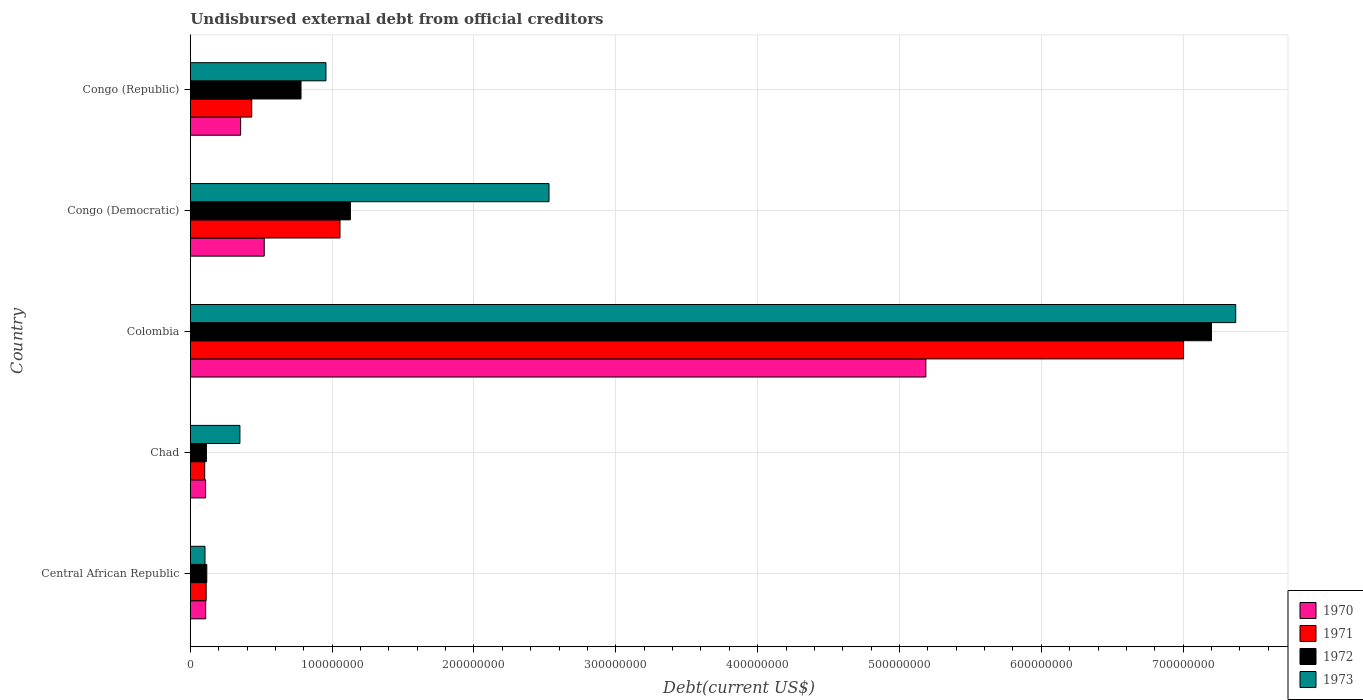How many different coloured bars are there?
Offer a terse response. 4. Are the number of bars per tick equal to the number of legend labels?
Ensure brevity in your answer.  Yes. How many bars are there on the 4th tick from the top?
Offer a very short reply. 4. How many bars are there on the 5th tick from the bottom?
Keep it short and to the point. 4. What is the label of the 3rd group of bars from the top?
Offer a very short reply. Colombia. In how many cases, is the number of bars for a given country not equal to the number of legend labels?
Your answer should be compact. 0. What is the total debt in 1972 in Congo (Democratic)?
Provide a short and direct response. 1.13e+08. Across all countries, what is the maximum total debt in 1972?
Make the answer very short. 7.20e+08. Across all countries, what is the minimum total debt in 1970?
Provide a short and direct response. 1.08e+07. In which country was the total debt in 1971 maximum?
Ensure brevity in your answer.  Colombia. In which country was the total debt in 1973 minimum?
Ensure brevity in your answer.  Central African Republic. What is the total total debt in 1972 in the graph?
Provide a short and direct response. 9.34e+08. What is the difference between the total debt in 1972 in Colombia and that in Congo (Democratic)?
Keep it short and to the point. 6.07e+08. What is the difference between the total debt in 1970 in Chad and the total debt in 1973 in Central African Republic?
Your answer should be compact. 4.25e+05. What is the average total debt in 1973 per country?
Your answer should be very brief. 2.26e+08. What is the difference between the total debt in 1972 and total debt in 1970 in Central African Republic?
Offer a very short reply. 7.88e+05. In how many countries, is the total debt in 1973 greater than 240000000 US$?
Provide a short and direct response. 2. What is the ratio of the total debt in 1972 in Central African Republic to that in Colombia?
Your answer should be compact. 0.02. Is the total debt in 1973 in Central African Republic less than that in Congo (Democratic)?
Ensure brevity in your answer.  Yes. What is the difference between the highest and the second highest total debt in 1971?
Make the answer very short. 5.95e+08. What is the difference between the highest and the lowest total debt in 1973?
Provide a short and direct response. 7.27e+08. In how many countries, is the total debt in 1970 greater than the average total debt in 1970 taken over all countries?
Ensure brevity in your answer.  1. Is the sum of the total debt in 1971 in Central African Republic and Colombia greater than the maximum total debt in 1973 across all countries?
Your answer should be compact. No. What does the 2nd bar from the bottom in Chad represents?
Provide a succinct answer. 1971. Are all the bars in the graph horizontal?
Your response must be concise. Yes. Are the values on the major ticks of X-axis written in scientific E-notation?
Keep it short and to the point. No. Does the graph contain any zero values?
Ensure brevity in your answer.  No. Where does the legend appear in the graph?
Offer a terse response. Bottom right. How are the legend labels stacked?
Offer a terse response. Vertical. What is the title of the graph?
Your answer should be very brief. Undisbursed external debt from official creditors. Does "1994" appear as one of the legend labels in the graph?
Give a very brief answer. No. What is the label or title of the X-axis?
Make the answer very short. Debt(current US$). What is the label or title of the Y-axis?
Your response must be concise. Country. What is the Debt(current US$) in 1970 in Central African Republic?
Ensure brevity in your answer.  1.08e+07. What is the Debt(current US$) in 1971 in Central African Republic?
Ensure brevity in your answer.  1.12e+07. What is the Debt(current US$) of 1972 in Central African Republic?
Offer a very short reply. 1.16e+07. What is the Debt(current US$) of 1973 in Central African Republic?
Keep it short and to the point. 1.04e+07. What is the Debt(current US$) of 1970 in Chad?
Provide a short and direct response. 1.08e+07. What is the Debt(current US$) of 1971 in Chad?
Offer a very short reply. 1.02e+07. What is the Debt(current US$) in 1972 in Chad?
Give a very brief answer. 1.14e+07. What is the Debt(current US$) in 1973 in Chad?
Make the answer very short. 3.50e+07. What is the Debt(current US$) of 1970 in Colombia?
Offer a terse response. 5.19e+08. What is the Debt(current US$) in 1971 in Colombia?
Keep it short and to the point. 7.00e+08. What is the Debt(current US$) of 1972 in Colombia?
Offer a terse response. 7.20e+08. What is the Debt(current US$) of 1973 in Colombia?
Provide a short and direct response. 7.37e+08. What is the Debt(current US$) in 1970 in Congo (Democratic)?
Offer a terse response. 5.21e+07. What is the Debt(current US$) in 1971 in Congo (Democratic)?
Make the answer very short. 1.06e+08. What is the Debt(current US$) of 1972 in Congo (Democratic)?
Offer a terse response. 1.13e+08. What is the Debt(current US$) in 1973 in Congo (Democratic)?
Offer a very short reply. 2.53e+08. What is the Debt(current US$) of 1970 in Congo (Republic)?
Offer a terse response. 3.55e+07. What is the Debt(current US$) in 1971 in Congo (Republic)?
Ensure brevity in your answer.  4.33e+07. What is the Debt(current US$) in 1972 in Congo (Republic)?
Your answer should be compact. 7.81e+07. What is the Debt(current US$) in 1973 in Congo (Republic)?
Your answer should be compact. 9.56e+07. Across all countries, what is the maximum Debt(current US$) in 1970?
Offer a very short reply. 5.19e+08. Across all countries, what is the maximum Debt(current US$) of 1971?
Your answer should be compact. 7.00e+08. Across all countries, what is the maximum Debt(current US$) in 1972?
Offer a terse response. 7.20e+08. Across all countries, what is the maximum Debt(current US$) in 1973?
Offer a terse response. 7.37e+08. Across all countries, what is the minimum Debt(current US$) of 1970?
Offer a very short reply. 1.08e+07. Across all countries, what is the minimum Debt(current US$) of 1971?
Provide a short and direct response. 1.02e+07. Across all countries, what is the minimum Debt(current US$) in 1972?
Provide a short and direct response. 1.14e+07. Across all countries, what is the minimum Debt(current US$) in 1973?
Your response must be concise. 1.04e+07. What is the total Debt(current US$) in 1970 in the graph?
Provide a succinct answer. 6.28e+08. What is the total Debt(current US$) of 1971 in the graph?
Provide a succinct answer. 8.70e+08. What is the total Debt(current US$) of 1972 in the graph?
Provide a short and direct response. 9.34e+08. What is the total Debt(current US$) in 1973 in the graph?
Keep it short and to the point. 1.13e+09. What is the difference between the Debt(current US$) in 1970 in Central African Republic and that in Chad?
Give a very brief answer. 5.50e+04. What is the difference between the Debt(current US$) in 1971 in Central African Republic and that in Chad?
Provide a succinct answer. 1.04e+06. What is the difference between the Debt(current US$) of 1972 in Central African Republic and that in Chad?
Your answer should be very brief. 2.79e+05. What is the difference between the Debt(current US$) of 1973 in Central African Republic and that in Chad?
Provide a succinct answer. -2.46e+07. What is the difference between the Debt(current US$) in 1970 in Central African Republic and that in Colombia?
Offer a very short reply. -5.08e+08. What is the difference between the Debt(current US$) of 1971 in Central African Republic and that in Colombia?
Provide a succinct answer. -6.89e+08. What is the difference between the Debt(current US$) in 1972 in Central African Republic and that in Colombia?
Offer a very short reply. -7.08e+08. What is the difference between the Debt(current US$) of 1973 in Central African Republic and that in Colombia?
Your answer should be compact. -7.27e+08. What is the difference between the Debt(current US$) of 1970 in Central African Republic and that in Congo (Democratic)?
Your answer should be compact. -4.13e+07. What is the difference between the Debt(current US$) of 1971 in Central African Republic and that in Congo (Democratic)?
Provide a succinct answer. -9.44e+07. What is the difference between the Debt(current US$) of 1972 in Central African Republic and that in Congo (Democratic)?
Ensure brevity in your answer.  -1.01e+08. What is the difference between the Debt(current US$) in 1973 in Central African Republic and that in Congo (Democratic)?
Offer a terse response. -2.43e+08. What is the difference between the Debt(current US$) in 1970 in Central African Republic and that in Congo (Republic)?
Keep it short and to the point. -2.46e+07. What is the difference between the Debt(current US$) in 1971 in Central African Republic and that in Congo (Republic)?
Offer a terse response. -3.21e+07. What is the difference between the Debt(current US$) in 1972 in Central African Republic and that in Congo (Republic)?
Make the answer very short. -6.64e+07. What is the difference between the Debt(current US$) of 1973 in Central African Republic and that in Congo (Republic)?
Give a very brief answer. -8.53e+07. What is the difference between the Debt(current US$) of 1970 in Chad and that in Colombia?
Your answer should be compact. -5.08e+08. What is the difference between the Debt(current US$) of 1971 in Chad and that in Colombia?
Give a very brief answer. -6.90e+08. What is the difference between the Debt(current US$) in 1972 in Chad and that in Colombia?
Your answer should be compact. -7.09e+08. What is the difference between the Debt(current US$) in 1973 in Chad and that in Colombia?
Your response must be concise. -7.02e+08. What is the difference between the Debt(current US$) in 1970 in Chad and that in Congo (Democratic)?
Your answer should be compact. -4.13e+07. What is the difference between the Debt(current US$) in 1971 in Chad and that in Congo (Democratic)?
Provide a short and direct response. -9.54e+07. What is the difference between the Debt(current US$) of 1972 in Chad and that in Congo (Democratic)?
Your response must be concise. -1.02e+08. What is the difference between the Debt(current US$) in 1973 in Chad and that in Congo (Democratic)?
Your answer should be very brief. -2.18e+08. What is the difference between the Debt(current US$) in 1970 in Chad and that in Congo (Republic)?
Make the answer very short. -2.47e+07. What is the difference between the Debt(current US$) in 1971 in Chad and that in Congo (Republic)?
Provide a short and direct response. -3.32e+07. What is the difference between the Debt(current US$) of 1972 in Chad and that in Congo (Republic)?
Your answer should be compact. -6.67e+07. What is the difference between the Debt(current US$) in 1973 in Chad and that in Congo (Republic)?
Your answer should be compact. -6.07e+07. What is the difference between the Debt(current US$) of 1970 in Colombia and that in Congo (Democratic)?
Keep it short and to the point. 4.66e+08. What is the difference between the Debt(current US$) of 1971 in Colombia and that in Congo (Democratic)?
Provide a short and direct response. 5.95e+08. What is the difference between the Debt(current US$) in 1972 in Colombia and that in Congo (Democratic)?
Your answer should be very brief. 6.07e+08. What is the difference between the Debt(current US$) of 1973 in Colombia and that in Congo (Democratic)?
Ensure brevity in your answer.  4.84e+08. What is the difference between the Debt(current US$) of 1970 in Colombia and that in Congo (Republic)?
Keep it short and to the point. 4.83e+08. What is the difference between the Debt(current US$) of 1971 in Colombia and that in Congo (Republic)?
Your response must be concise. 6.57e+08. What is the difference between the Debt(current US$) in 1972 in Colombia and that in Congo (Republic)?
Your response must be concise. 6.42e+08. What is the difference between the Debt(current US$) in 1973 in Colombia and that in Congo (Republic)?
Provide a succinct answer. 6.41e+08. What is the difference between the Debt(current US$) of 1970 in Congo (Democratic) and that in Congo (Republic)?
Offer a very short reply. 1.66e+07. What is the difference between the Debt(current US$) in 1971 in Congo (Democratic) and that in Congo (Republic)?
Offer a very short reply. 6.22e+07. What is the difference between the Debt(current US$) of 1972 in Congo (Democratic) and that in Congo (Republic)?
Offer a terse response. 3.48e+07. What is the difference between the Debt(current US$) in 1973 in Congo (Democratic) and that in Congo (Republic)?
Ensure brevity in your answer.  1.57e+08. What is the difference between the Debt(current US$) of 1970 in Central African Republic and the Debt(current US$) of 1971 in Chad?
Make the answer very short. 6.94e+05. What is the difference between the Debt(current US$) in 1970 in Central African Republic and the Debt(current US$) in 1972 in Chad?
Ensure brevity in your answer.  -5.09e+05. What is the difference between the Debt(current US$) of 1970 in Central African Republic and the Debt(current US$) of 1973 in Chad?
Offer a very short reply. -2.41e+07. What is the difference between the Debt(current US$) of 1971 in Central African Republic and the Debt(current US$) of 1972 in Chad?
Your answer should be compact. -1.65e+05. What is the difference between the Debt(current US$) in 1971 in Central African Republic and the Debt(current US$) in 1973 in Chad?
Keep it short and to the point. -2.38e+07. What is the difference between the Debt(current US$) in 1972 in Central African Republic and the Debt(current US$) in 1973 in Chad?
Ensure brevity in your answer.  -2.34e+07. What is the difference between the Debt(current US$) of 1970 in Central African Republic and the Debt(current US$) of 1971 in Colombia?
Your answer should be compact. -6.89e+08. What is the difference between the Debt(current US$) of 1970 in Central African Republic and the Debt(current US$) of 1972 in Colombia?
Give a very brief answer. -7.09e+08. What is the difference between the Debt(current US$) of 1970 in Central African Republic and the Debt(current US$) of 1973 in Colombia?
Your answer should be very brief. -7.26e+08. What is the difference between the Debt(current US$) in 1971 in Central African Republic and the Debt(current US$) in 1972 in Colombia?
Ensure brevity in your answer.  -7.09e+08. What is the difference between the Debt(current US$) in 1971 in Central African Republic and the Debt(current US$) in 1973 in Colombia?
Provide a succinct answer. -7.26e+08. What is the difference between the Debt(current US$) in 1972 in Central African Republic and the Debt(current US$) in 1973 in Colombia?
Your response must be concise. -7.25e+08. What is the difference between the Debt(current US$) of 1970 in Central African Republic and the Debt(current US$) of 1971 in Congo (Democratic)?
Offer a very short reply. -9.47e+07. What is the difference between the Debt(current US$) of 1970 in Central African Republic and the Debt(current US$) of 1972 in Congo (Democratic)?
Make the answer very short. -1.02e+08. What is the difference between the Debt(current US$) of 1970 in Central African Republic and the Debt(current US$) of 1973 in Congo (Democratic)?
Give a very brief answer. -2.42e+08. What is the difference between the Debt(current US$) of 1971 in Central African Republic and the Debt(current US$) of 1972 in Congo (Democratic)?
Provide a short and direct response. -1.02e+08. What is the difference between the Debt(current US$) in 1971 in Central African Republic and the Debt(current US$) in 1973 in Congo (Democratic)?
Keep it short and to the point. -2.42e+08. What is the difference between the Debt(current US$) of 1972 in Central African Republic and the Debt(current US$) of 1973 in Congo (Democratic)?
Provide a succinct answer. -2.41e+08. What is the difference between the Debt(current US$) of 1970 in Central African Republic and the Debt(current US$) of 1971 in Congo (Republic)?
Your answer should be compact. -3.25e+07. What is the difference between the Debt(current US$) in 1970 in Central African Republic and the Debt(current US$) in 1972 in Congo (Republic)?
Your answer should be compact. -6.72e+07. What is the difference between the Debt(current US$) of 1970 in Central African Republic and the Debt(current US$) of 1973 in Congo (Republic)?
Make the answer very short. -8.48e+07. What is the difference between the Debt(current US$) of 1971 in Central African Republic and the Debt(current US$) of 1972 in Congo (Republic)?
Provide a short and direct response. -6.69e+07. What is the difference between the Debt(current US$) in 1971 in Central African Republic and the Debt(current US$) in 1973 in Congo (Republic)?
Ensure brevity in your answer.  -8.45e+07. What is the difference between the Debt(current US$) of 1972 in Central African Republic and the Debt(current US$) of 1973 in Congo (Republic)?
Provide a succinct answer. -8.40e+07. What is the difference between the Debt(current US$) in 1970 in Chad and the Debt(current US$) in 1971 in Colombia?
Offer a terse response. -6.89e+08. What is the difference between the Debt(current US$) in 1970 in Chad and the Debt(current US$) in 1972 in Colombia?
Your response must be concise. -7.09e+08. What is the difference between the Debt(current US$) of 1970 in Chad and the Debt(current US$) of 1973 in Colombia?
Make the answer very short. -7.26e+08. What is the difference between the Debt(current US$) in 1971 in Chad and the Debt(current US$) in 1972 in Colombia?
Provide a succinct answer. -7.10e+08. What is the difference between the Debt(current US$) of 1971 in Chad and the Debt(current US$) of 1973 in Colombia?
Offer a very short reply. -7.27e+08. What is the difference between the Debt(current US$) of 1972 in Chad and the Debt(current US$) of 1973 in Colombia?
Provide a short and direct response. -7.26e+08. What is the difference between the Debt(current US$) in 1970 in Chad and the Debt(current US$) in 1971 in Congo (Democratic)?
Your answer should be compact. -9.48e+07. What is the difference between the Debt(current US$) of 1970 in Chad and the Debt(current US$) of 1972 in Congo (Democratic)?
Offer a very short reply. -1.02e+08. What is the difference between the Debt(current US$) in 1970 in Chad and the Debt(current US$) in 1973 in Congo (Democratic)?
Your response must be concise. -2.42e+08. What is the difference between the Debt(current US$) in 1971 in Chad and the Debt(current US$) in 1972 in Congo (Democratic)?
Make the answer very short. -1.03e+08. What is the difference between the Debt(current US$) of 1971 in Chad and the Debt(current US$) of 1973 in Congo (Democratic)?
Provide a short and direct response. -2.43e+08. What is the difference between the Debt(current US$) of 1972 in Chad and the Debt(current US$) of 1973 in Congo (Democratic)?
Provide a succinct answer. -2.42e+08. What is the difference between the Debt(current US$) in 1970 in Chad and the Debt(current US$) in 1971 in Congo (Republic)?
Make the answer very short. -3.25e+07. What is the difference between the Debt(current US$) in 1970 in Chad and the Debt(current US$) in 1972 in Congo (Republic)?
Provide a succinct answer. -6.73e+07. What is the difference between the Debt(current US$) of 1970 in Chad and the Debt(current US$) of 1973 in Congo (Republic)?
Make the answer very short. -8.49e+07. What is the difference between the Debt(current US$) in 1971 in Chad and the Debt(current US$) in 1972 in Congo (Republic)?
Give a very brief answer. -6.79e+07. What is the difference between the Debt(current US$) in 1971 in Chad and the Debt(current US$) in 1973 in Congo (Republic)?
Your answer should be very brief. -8.55e+07. What is the difference between the Debt(current US$) in 1972 in Chad and the Debt(current US$) in 1973 in Congo (Republic)?
Offer a terse response. -8.43e+07. What is the difference between the Debt(current US$) in 1970 in Colombia and the Debt(current US$) in 1971 in Congo (Democratic)?
Offer a terse response. 4.13e+08. What is the difference between the Debt(current US$) in 1970 in Colombia and the Debt(current US$) in 1972 in Congo (Democratic)?
Your answer should be very brief. 4.06e+08. What is the difference between the Debt(current US$) of 1970 in Colombia and the Debt(current US$) of 1973 in Congo (Democratic)?
Provide a short and direct response. 2.66e+08. What is the difference between the Debt(current US$) in 1971 in Colombia and the Debt(current US$) in 1972 in Congo (Democratic)?
Offer a terse response. 5.87e+08. What is the difference between the Debt(current US$) of 1971 in Colombia and the Debt(current US$) of 1973 in Congo (Democratic)?
Provide a succinct answer. 4.47e+08. What is the difference between the Debt(current US$) in 1972 in Colombia and the Debt(current US$) in 1973 in Congo (Democratic)?
Offer a terse response. 4.67e+08. What is the difference between the Debt(current US$) of 1970 in Colombia and the Debt(current US$) of 1971 in Congo (Republic)?
Give a very brief answer. 4.75e+08. What is the difference between the Debt(current US$) in 1970 in Colombia and the Debt(current US$) in 1972 in Congo (Republic)?
Ensure brevity in your answer.  4.41e+08. What is the difference between the Debt(current US$) of 1970 in Colombia and the Debt(current US$) of 1973 in Congo (Republic)?
Your response must be concise. 4.23e+08. What is the difference between the Debt(current US$) of 1971 in Colombia and the Debt(current US$) of 1972 in Congo (Republic)?
Ensure brevity in your answer.  6.22e+08. What is the difference between the Debt(current US$) of 1971 in Colombia and the Debt(current US$) of 1973 in Congo (Republic)?
Your response must be concise. 6.05e+08. What is the difference between the Debt(current US$) in 1972 in Colombia and the Debt(current US$) in 1973 in Congo (Republic)?
Ensure brevity in your answer.  6.24e+08. What is the difference between the Debt(current US$) of 1970 in Congo (Democratic) and the Debt(current US$) of 1971 in Congo (Republic)?
Your response must be concise. 8.81e+06. What is the difference between the Debt(current US$) of 1970 in Congo (Democratic) and the Debt(current US$) of 1972 in Congo (Republic)?
Make the answer very short. -2.59e+07. What is the difference between the Debt(current US$) of 1970 in Congo (Democratic) and the Debt(current US$) of 1973 in Congo (Republic)?
Keep it short and to the point. -4.35e+07. What is the difference between the Debt(current US$) of 1971 in Congo (Democratic) and the Debt(current US$) of 1972 in Congo (Republic)?
Give a very brief answer. 2.75e+07. What is the difference between the Debt(current US$) of 1971 in Congo (Democratic) and the Debt(current US$) of 1973 in Congo (Republic)?
Keep it short and to the point. 9.89e+06. What is the difference between the Debt(current US$) of 1972 in Congo (Democratic) and the Debt(current US$) of 1973 in Congo (Republic)?
Make the answer very short. 1.72e+07. What is the average Debt(current US$) of 1970 per country?
Offer a very short reply. 1.26e+08. What is the average Debt(current US$) in 1971 per country?
Your answer should be very brief. 1.74e+08. What is the average Debt(current US$) in 1972 per country?
Ensure brevity in your answer.  1.87e+08. What is the average Debt(current US$) in 1973 per country?
Your response must be concise. 2.26e+08. What is the difference between the Debt(current US$) of 1970 and Debt(current US$) of 1971 in Central African Republic?
Your answer should be compact. -3.44e+05. What is the difference between the Debt(current US$) in 1970 and Debt(current US$) in 1972 in Central African Republic?
Provide a succinct answer. -7.88e+05. What is the difference between the Debt(current US$) in 1971 and Debt(current US$) in 1972 in Central African Republic?
Provide a short and direct response. -4.44e+05. What is the difference between the Debt(current US$) of 1971 and Debt(current US$) of 1973 in Central African Republic?
Provide a short and direct response. 8.24e+05. What is the difference between the Debt(current US$) of 1972 and Debt(current US$) of 1973 in Central African Republic?
Make the answer very short. 1.27e+06. What is the difference between the Debt(current US$) of 1970 and Debt(current US$) of 1971 in Chad?
Your answer should be compact. 6.39e+05. What is the difference between the Debt(current US$) in 1970 and Debt(current US$) in 1972 in Chad?
Your response must be concise. -5.64e+05. What is the difference between the Debt(current US$) in 1970 and Debt(current US$) in 1973 in Chad?
Offer a terse response. -2.42e+07. What is the difference between the Debt(current US$) of 1971 and Debt(current US$) of 1972 in Chad?
Offer a terse response. -1.20e+06. What is the difference between the Debt(current US$) of 1971 and Debt(current US$) of 1973 in Chad?
Ensure brevity in your answer.  -2.48e+07. What is the difference between the Debt(current US$) in 1972 and Debt(current US$) in 1973 in Chad?
Give a very brief answer. -2.36e+07. What is the difference between the Debt(current US$) of 1970 and Debt(current US$) of 1971 in Colombia?
Make the answer very short. -1.82e+08. What is the difference between the Debt(current US$) in 1970 and Debt(current US$) in 1972 in Colombia?
Your answer should be very brief. -2.01e+08. What is the difference between the Debt(current US$) in 1970 and Debt(current US$) in 1973 in Colombia?
Your answer should be compact. -2.18e+08. What is the difference between the Debt(current US$) of 1971 and Debt(current US$) of 1972 in Colombia?
Your answer should be compact. -1.97e+07. What is the difference between the Debt(current US$) in 1971 and Debt(current US$) in 1973 in Colombia?
Your answer should be very brief. -3.68e+07. What is the difference between the Debt(current US$) of 1972 and Debt(current US$) of 1973 in Colombia?
Your response must be concise. -1.71e+07. What is the difference between the Debt(current US$) of 1970 and Debt(current US$) of 1971 in Congo (Democratic)?
Provide a succinct answer. -5.34e+07. What is the difference between the Debt(current US$) of 1970 and Debt(current US$) of 1972 in Congo (Democratic)?
Ensure brevity in your answer.  -6.07e+07. What is the difference between the Debt(current US$) in 1970 and Debt(current US$) in 1973 in Congo (Democratic)?
Provide a short and direct response. -2.01e+08. What is the difference between the Debt(current US$) of 1971 and Debt(current US$) of 1972 in Congo (Democratic)?
Offer a very short reply. -7.32e+06. What is the difference between the Debt(current US$) of 1971 and Debt(current US$) of 1973 in Congo (Democratic)?
Keep it short and to the point. -1.47e+08. What is the difference between the Debt(current US$) of 1972 and Debt(current US$) of 1973 in Congo (Democratic)?
Make the answer very short. -1.40e+08. What is the difference between the Debt(current US$) in 1970 and Debt(current US$) in 1971 in Congo (Republic)?
Give a very brief answer. -7.82e+06. What is the difference between the Debt(current US$) in 1970 and Debt(current US$) in 1972 in Congo (Republic)?
Your answer should be compact. -4.26e+07. What is the difference between the Debt(current US$) in 1970 and Debt(current US$) in 1973 in Congo (Republic)?
Your response must be concise. -6.02e+07. What is the difference between the Debt(current US$) in 1971 and Debt(current US$) in 1972 in Congo (Republic)?
Ensure brevity in your answer.  -3.47e+07. What is the difference between the Debt(current US$) of 1971 and Debt(current US$) of 1973 in Congo (Republic)?
Offer a very short reply. -5.23e+07. What is the difference between the Debt(current US$) in 1972 and Debt(current US$) in 1973 in Congo (Republic)?
Give a very brief answer. -1.76e+07. What is the ratio of the Debt(current US$) in 1971 in Central African Republic to that in Chad?
Make the answer very short. 1.1. What is the ratio of the Debt(current US$) of 1972 in Central African Republic to that in Chad?
Your answer should be very brief. 1.02. What is the ratio of the Debt(current US$) in 1973 in Central African Republic to that in Chad?
Ensure brevity in your answer.  0.3. What is the ratio of the Debt(current US$) in 1970 in Central African Republic to that in Colombia?
Provide a succinct answer. 0.02. What is the ratio of the Debt(current US$) of 1971 in Central African Republic to that in Colombia?
Your answer should be compact. 0.02. What is the ratio of the Debt(current US$) of 1972 in Central African Republic to that in Colombia?
Give a very brief answer. 0.02. What is the ratio of the Debt(current US$) in 1973 in Central African Republic to that in Colombia?
Offer a terse response. 0.01. What is the ratio of the Debt(current US$) in 1970 in Central African Republic to that in Congo (Democratic)?
Provide a succinct answer. 0.21. What is the ratio of the Debt(current US$) of 1971 in Central African Republic to that in Congo (Democratic)?
Ensure brevity in your answer.  0.11. What is the ratio of the Debt(current US$) of 1972 in Central African Republic to that in Congo (Democratic)?
Ensure brevity in your answer.  0.1. What is the ratio of the Debt(current US$) of 1973 in Central African Republic to that in Congo (Democratic)?
Your response must be concise. 0.04. What is the ratio of the Debt(current US$) in 1970 in Central African Republic to that in Congo (Republic)?
Ensure brevity in your answer.  0.31. What is the ratio of the Debt(current US$) in 1971 in Central African Republic to that in Congo (Republic)?
Provide a short and direct response. 0.26. What is the ratio of the Debt(current US$) of 1972 in Central African Republic to that in Congo (Republic)?
Your answer should be compact. 0.15. What is the ratio of the Debt(current US$) of 1973 in Central African Republic to that in Congo (Republic)?
Offer a terse response. 0.11. What is the ratio of the Debt(current US$) of 1970 in Chad to that in Colombia?
Provide a short and direct response. 0.02. What is the ratio of the Debt(current US$) of 1971 in Chad to that in Colombia?
Give a very brief answer. 0.01. What is the ratio of the Debt(current US$) in 1972 in Chad to that in Colombia?
Provide a succinct answer. 0.02. What is the ratio of the Debt(current US$) in 1973 in Chad to that in Colombia?
Provide a succinct answer. 0.05. What is the ratio of the Debt(current US$) in 1970 in Chad to that in Congo (Democratic)?
Your answer should be very brief. 0.21. What is the ratio of the Debt(current US$) in 1971 in Chad to that in Congo (Democratic)?
Provide a short and direct response. 0.1. What is the ratio of the Debt(current US$) in 1972 in Chad to that in Congo (Democratic)?
Provide a short and direct response. 0.1. What is the ratio of the Debt(current US$) in 1973 in Chad to that in Congo (Democratic)?
Your response must be concise. 0.14. What is the ratio of the Debt(current US$) in 1970 in Chad to that in Congo (Republic)?
Provide a succinct answer. 0.3. What is the ratio of the Debt(current US$) in 1971 in Chad to that in Congo (Republic)?
Make the answer very short. 0.23. What is the ratio of the Debt(current US$) in 1972 in Chad to that in Congo (Republic)?
Provide a succinct answer. 0.15. What is the ratio of the Debt(current US$) of 1973 in Chad to that in Congo (Republic)?
Ensure brevity in your answer.  0.37. What is the ratio of the Debt(current US$) of 1970 in Colombia to that in Congo (Democratic)?
Offer a terse response. 9.95. What is the ratio of the Debt(current US$) in 1971 in Colombia to that in Congo (Democratic)?
Your answer should be compact. 6.63. What is the ratio of the Debt(current US$) of 1972 in Colombia to that in Congo (Democratic)?
Keep it short and to the point. 6.38. What is the ratio of the Debt(current US$) of 1973 in Colombia to that in Congo (Democratic)?
Offer a terse response. 2.91. What is the ratio of the Debt(current US$) of 1970 in Colombia to that in Congo (Republic)?
Your answer should be compact. 14.61. What is the ratio of the Debt(current US$) of 1971 in Colombia to that in Congo (Republic)?
Make the answer very short. 16.17. What is the ratio of the Debt(current US$) in 1972 in Colombia to that in Congo (Republic)?
Keep it short and to the point. 9.22. What is the ratio of the Debt(current US$) of 1973 in Colombia to that in Congo (Republic)?
Your response must be concise. 7.71. What is the ratio of the Debt(current US$) in 1970 in Congo (Democratic) to that in Congo (Republic)?
Provide a succinct answer. 1.47. What is the ratio of the Debt(current US$) in 1971 in Congo (Democratic) to that in Congo (Republic)?
Offer a terse response. 2.44. What is the ratio of the Debt(current US$) in 1972 in Congo (Democratic) to that in Congo (Republic)?
Ensure brevity in your answer.  1.45. What is the ratio of the Debt(current US$) of 1973 in Congo (Democratic) to that in Congo (Republic)?
Give a very brief answer. 2.64. What is the difference between the highest and the second highest Debt(current US$) of 1970?
Offer a terse response. 4.66e+08. What is the difference between the highest and the second highest Debt(current US$) in 1971?
Ensure brevity in your answer.  5.95e+08. What is the difference between the highest and the second highest Debt(current US$) of 1972?
Ensure brevity in your answer.  6.07e+08. What is the difference between the highest and the second highest Debt(current US$) in 1973?
Provide a short and direct response. 4.84e+08. What is the difference between the highest and the lowest Debt(current US$) of 1970?
Provide a short and direct response. 5.08e+08. What is the difference between the highest and the lowest Debt(current US$) in 1971?
Keep it short and to the point. 6.90e+08. What is the difference between the highest and the lowest Debt(current US$) of 1972?
Offer a terse response. 7.09e+08. What is the difference between the highest and the lowest Debt(current US$) of 1973?
Your response must be concise. 7.27e+08. 